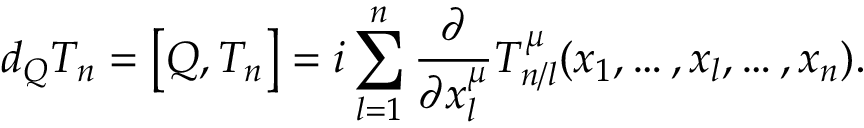Convert formula to latex. <formula><loc_0><loc_0><loc_500><loc_500>d _ { Q } T _ { n } = \left [ Q , T _ { n } \right ] = i \sum _ { l = 1 } ^ { n } \frac { \partial } { \partial x _ { l } ^ { \mu } } T _ { n / l } ^ { \mu } ( x _ { 1 } , \dots , x _ { l } , \dots , x _ { n } ) .</formula> 